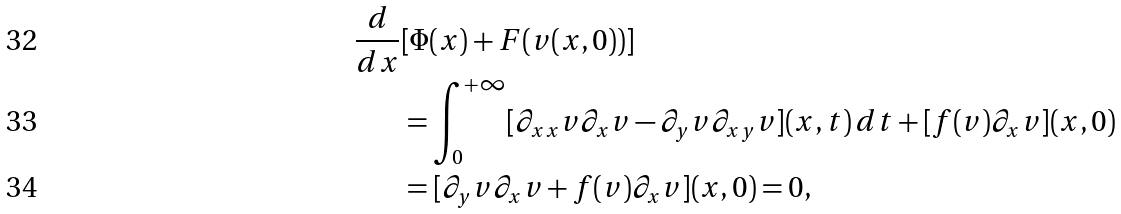Convert formula to latex. <formula><loc_0><loc_0><loc_500><loc_500>\frac { d } { d x } & [ \Phi ( x ) + F ( v ( x , 0 ) ) ] \\ & = \int _ { 0 } ^ { + \infty } [ \partial _ { x x } v \partial _ { x } v - \partial _ { y } v \partial _ { x y } v ] ( x , t ) \, d t + [ f ( v ) \partial _ { x } v ] ( x , 0 ) \\ & = [ \partial _ { y } v \partial _ { x } v + f ( v ) \partial _ { x } v ] ( x , 0 ) = 0 ,</formula> 